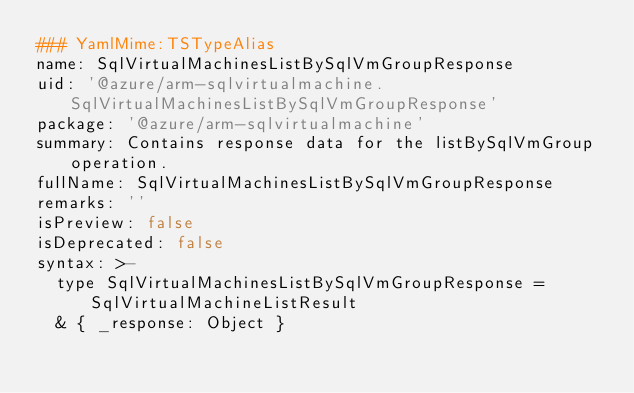<code> <loc_0><loc_0><loc_500><loc_500><_YAML_>### YamlMime:TSTypeAlias
name: SqlVirtualMachinesListBySqlVmGroupResponse
uid: '@azure/arm-sqlvirtualmachine.SqlVirtualMachinesListBySqlVmGroupResponse'
package: '@azure/arm-sqlvirtualmachine'
summary: Contains response data for the listBySqlVmGroup operation.
fullName: SqlVirtualMachinesListBySqlVmGroupResponse
remarks: ''
isPreview: false
isDeprecated: false
syntax: >-
  type SqlVirtualMachinesListBySqlVmGroupResponse = SqlVirtualMachineListResult
  & { _response: Object }
</code> 